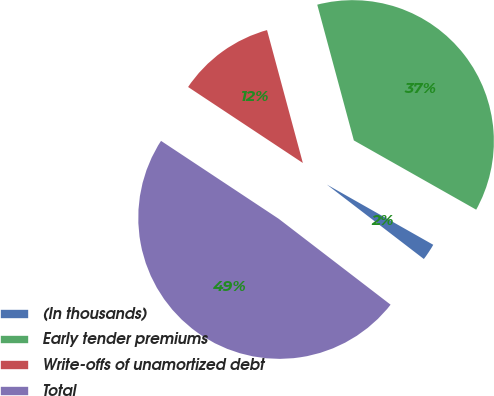<chart> <loc_0><loc_0><loc_500><loc_500><pie_chart><fcel>(In thousands)<fcel>Early tender premiums<fcel>Write-offs of unamortized debt<fcel>Total<nl><fcel>2.22%<fcel>37.39%<fcel>11.5%<fcel>48.89%<nl></chart> 